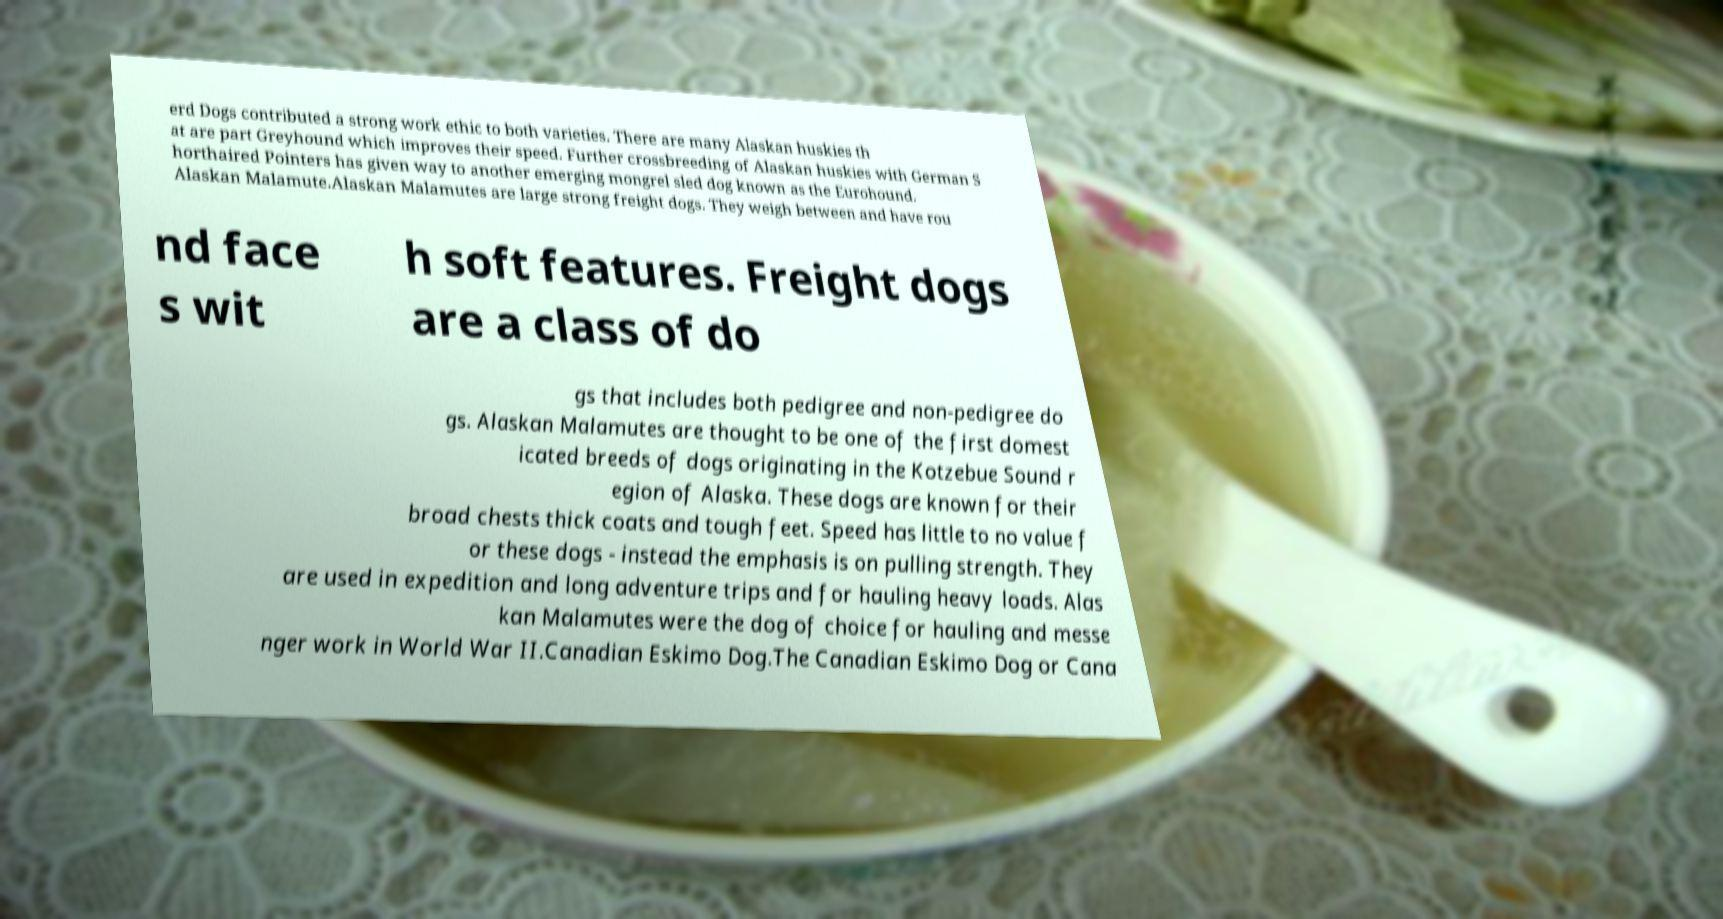Can you accurately transcribe the text from the provided image for me? erd Dogs contributed a strong work ethic to both varieties. There are many Alaskan huskies th at are part Greyhound which improves their speed. Further crossbreeding of Alaskan huskies with German S horthaired Pointers has given way to another emerging mongrel sled dog known as the Eurohound. Alaskan Malamute.Alaskan Malamutes are large strong freight dogs. They weigh between and have rou nd face s wit h soft features. Freight dogs are a class of do gs that includes both pedigree and non-pedigree do gs. Alaskan Malamutes are thought to be one of the first domest icated breeds of dogs originating in the Kotzebue Sound r egion of Alaska. These dogs are known for their broad chests thick coats and tough feet. Speed has little to no value f or these dogs - instead the emphasis is on pulling strength. They are used in expedition and long adventure trips and for hauling heavy loads. Alas kan Malamutes were the dog of choice for hauling and messe nger work in World War II.Canadian Eskimo Dog.The Canadian Eskimo Dog or Cana 